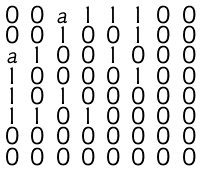Convert formula to latex. <formula><loc_0><loc_0><loc_500><loc_500>\begin{smallmatrix} 0 & 0 & a & 1 & 1 & 1 & 0 & 0 \\ 0 & 0 & 1 & 0 & 0 & 1 & 0 & 0 \\ a & 1 & 0 & 0 & 1 & 0 & 0 & 0 \\ 1 & 0 & 0 & 0 & 0 & 1 & 0 & 0 \\ 1 & 0 & 1 & 0 & 0 & 0 & 0 & 0 \\ 1 & 1 & 0 & 1 & 0 & 0 & 0 & 0 \\ 0 & 0 & 0 & 0 & 0 & 0 & 0 & 0 \\ 0 & 0 & 0 & 0 & 0 & 0 & 0 & 0 \end{smallmatrix}</formula> 